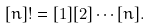<formula> <loc_0><loc_0><loc_500><loc_500>[ n ] ! = [ 1 ] [ 2 ] \cdots [ n ] .</formula> 